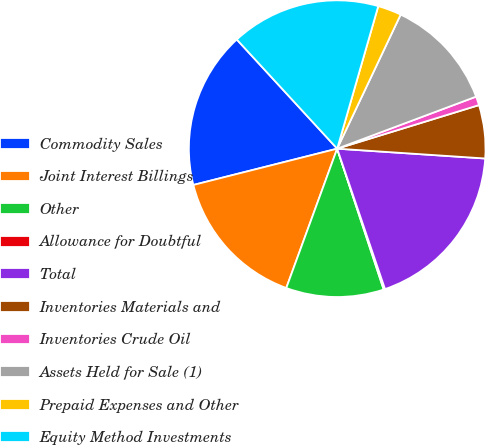<chart> <loc_0><loc_0><loc_500><loc_500><pie_chart><fcel>Commodity Sales<fcel>Joint Interest Billings<fcel>Other<fcel>Allowance for Doubtful<fcel>Total<fcel>Inventories Materials and<fcel>Inventories Crude Oil<fcel>Assets Held for Sale (1)<fcel>Prepaid Expenses and Other<fcel>Equity Method Investments<nl><fcel>17.1%<fcel>15.49%<fcel>10.65%<fcel>0.15%<fcel>18.72%<fcel>5.8%<fcel>0.96%<fcel>12.26%<fcel>2.57%<fcel>16.3%<nl></chart> 